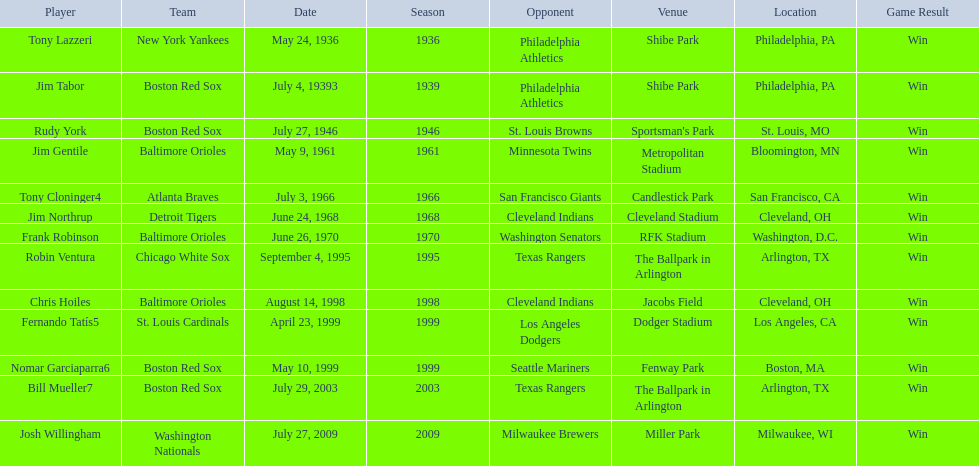Who were all of the players? Tony Lazzeri, Jim Tabor, Rudy York, Jim Gentile, Tony Cloninger4, Jim Northrup, Frank Robinson, Robin Ventura, Chris Hoiles, Fernando Tatís5, Nomar Garciaparra6, Bill Mueller7, Josh Willingham. What year was there a player for the yankees? May 24, 1936. What was the name of that 1936 yankees player? Tony Lazzeri. 